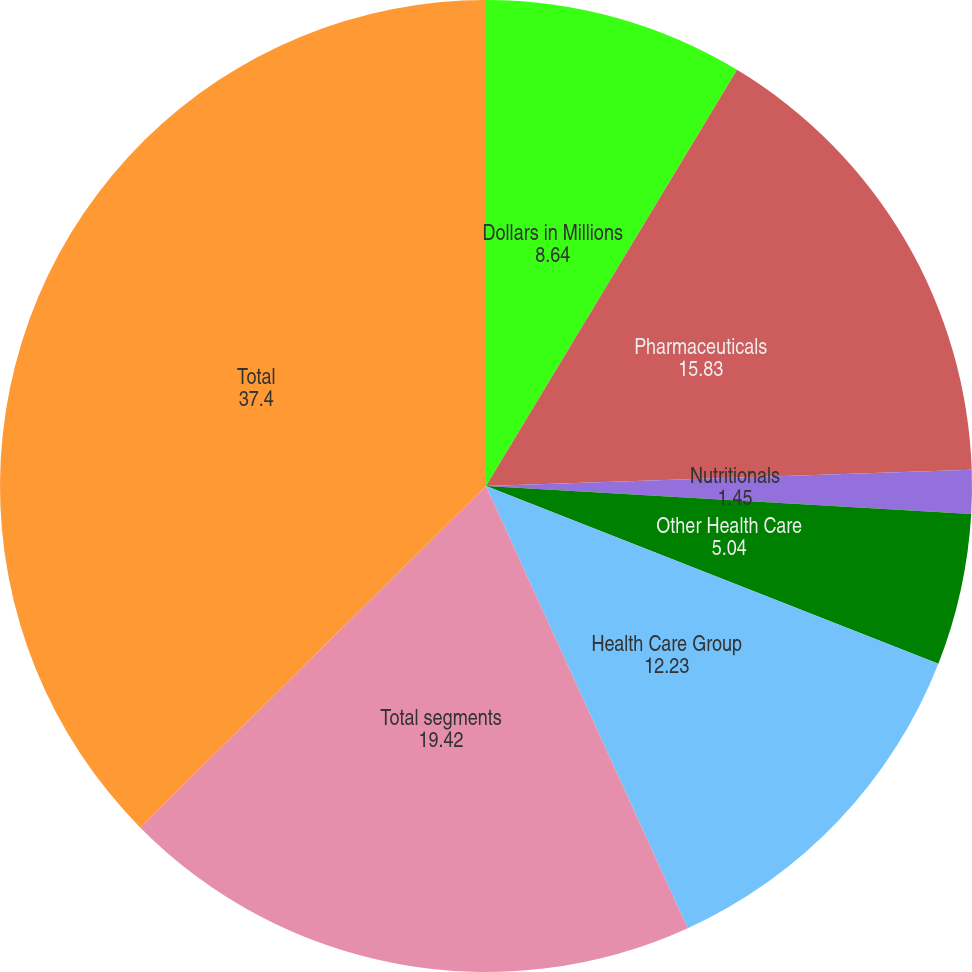Convert chart to OTSL. <chart><loc_0><loc_0><loc_500><loc_500><pie_chart><fcel>Dollars in Millions<fcel>Pharmaceuticals<fcel>Nutritionals<fcel>Other Health Care<fcel>Health Care Group<fcel>Total segments<fcel>Total<nl><fcel>8.64%<fcel>15.83%<fcel>1.45%<fcel>5.04%<fcel>12.23%<fcel>19.42%<fcel>37.4%<nl></chart> 